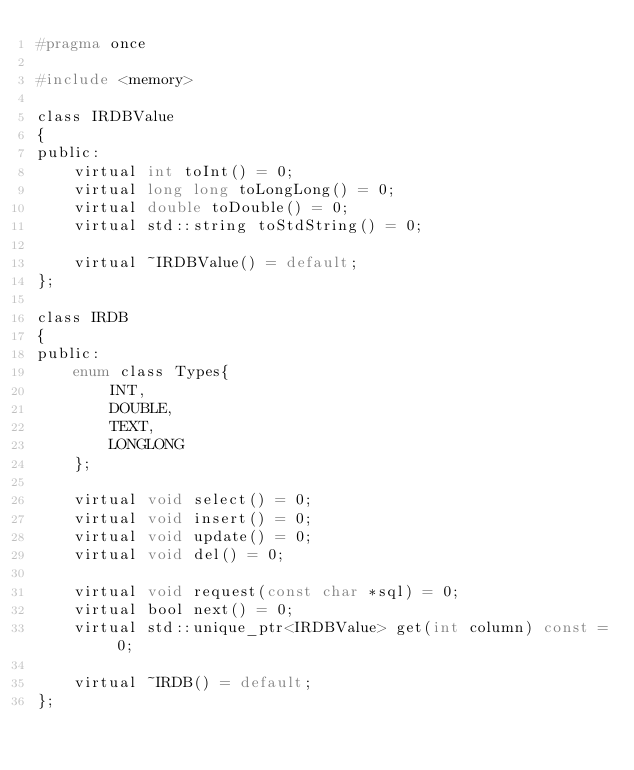Convert code to text. <code><loc_0><loc_0><loc_500><loc_500><_C_>#pragma once

#include <memory>

class IRDBValue
{
public:
    virtual int toInt() = 0;
    virtual long long toLongLong() = 0;
    virtual double toDouble() = 0;
    virtual std::string toStdString() = 0;

    virtual ~IRDBValue() = default;
};

class IRDB
{
public:
    enum class Types{
        INT,
        DOUBLE,
        TEXT,
        LONGLONG
    };

    virtual void select() = 0;
    virtual void insert() = 0;
    virtual void update() = 0;
    virtual void del() = 0;

    virtual void request(const char *sql) = 0;
    virtual bool next() = 0;
    virtual std::unique_ptr<IRDBValue> get(int column) const = 0;

    virtual ~IRDB() = default;
};
</code> 